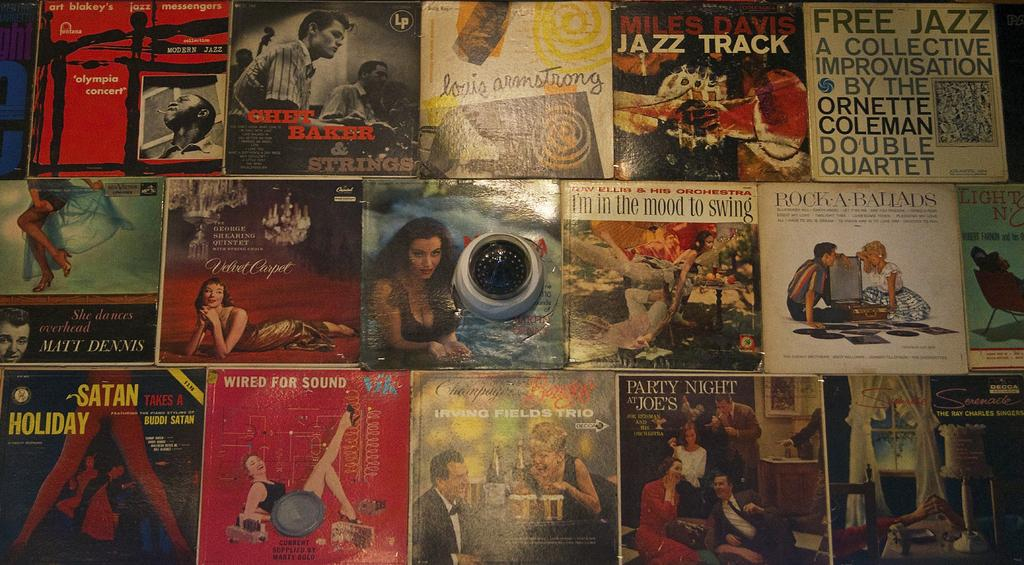<image>
Write a terse but informative summary of the picture. Cover of books placed next to one another with "I'm in the Mood" being in the middle. 